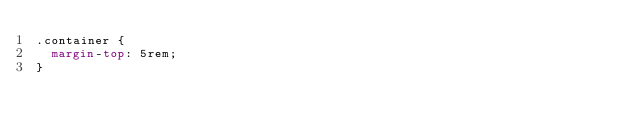Convert code to text. <code><loc_0><loc_0><loc_500><loc_500><_CSS_>.container {
  margin-top: 5rem;
}</code> 